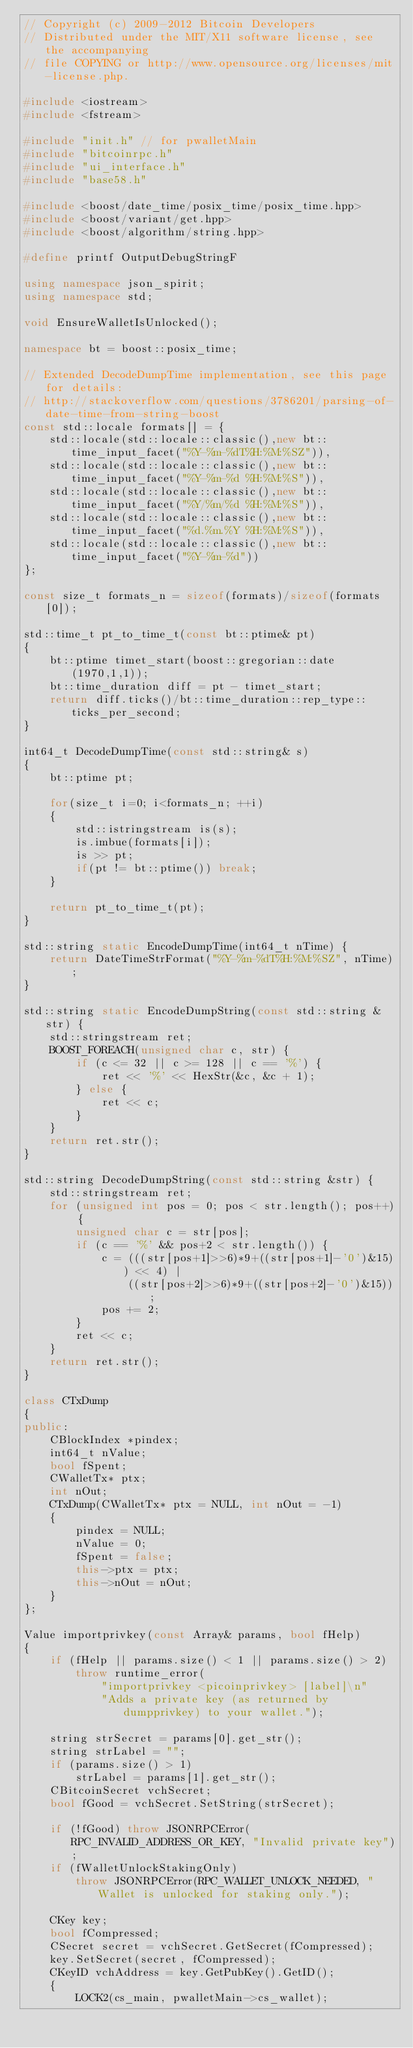<code> <loc_0><loc_0><loc_500><loc_500><_C++_>// Copyright (c) 2009-2012 Bitcoin Developers
// Distributed under the MIT/X11 software license, see the accompanying
// file COPYING or http://www.opensource.org/licenses/mit-license.php.

#include <iostream>
#include <fstream>

#include "init.h" // for pwalletMain
#include "bitcoinrpc.h"
#include "ui_interface.h"
#include "base58.h"

#include <boost/date_time/posix_time/posix_time.hpp>
#include <boost/variant/get.hpp>
#include <boost/algorithm/string.hpp>

#define printf OutputDebugStringF

using namespace json_spirit;
using namespace std;

void EnsureWalletIsUnlocked();

namespace bt = boost::posix_time;

// Extended DecodeDumpTime implementation, see this page for details:
// http://stackoverflow.com/questions/3786201/parsing-of-date-time-from-string-boost
const std::locale formats[] = {
    std::locale(std::locale::classic(),new bt::time_input_facet("%Y-%m-%dT%H:%M:%SZ")),
    std::locale(std::locale::classic(),new bt::time_input_facet("%Y-%m-%d %H:%M:%S")),
    std::locale(std::locale::classic(),new bt::time_input_facet("%Y/%m/%d %H:%M:%S")),
    std::locale(std::locale::classic(),new bt::time_input_facet("%d.%m.%Y %H:%M:%S")),
    std::locale(std::locale::classic(),new bt::time_input_facet("%Y-%m-%d"))
};

const size_t formats_n = sizeof(formats)/sizeof(formats[0]);

std::time_t pt_to_time_t(const bt::ptime& pt)
{
    bt::ptime timet_start(boost::gregorian::date(1970,1,1));
    bt::time_duration diff = pt - timet_start;
    return diff.ticks()/bt::time_duration::rep_type::ticks_per_second;
}

int64_t DecodeDumpTime(const std::string& s)
{
    bt::ptime pt;

    for(size_t i=0; i<formats_n; ++i)
    {
        std::istringstream is(s);
        is.imbue(formats[i]);
        is >> pt;
        if(pt != bt::ptime()) break;
    }

    return pt_to_time_t(pt);
}

std::string static EncodeDumpTime(int64_t nTime) {
    return DateTimeStrFormat("%Y-%m-%dT%H:%M:%SZ", nTime);
}

std::string static EncodeDumpString(const std::string &str) {
    std::stringstream ret;
    BOOST_FOREACH(unsigned char c, str) {
        if (c <= 32 || c >= 128 || c == '%') {
            ret << '%' << HexStr(&c, &c + 1);
        } else {
            ret << c;
        }
    }
    return ret.str();
}

std::string DecodeDumpString(const std::string &str) {
    std::stringstream ret;
    for (unsigned int pos = 0; pos < str.length(); pos++) {
        unsigned char c = str[pos];
        if (c == '%' && pos+2 < str.length()) {
            c = (((str[pos+1]>>6)*9+((str[pos+1]-'0')&15)) << 4) | 
                ((str[pos+2]>>6)*9+((str[pos+2]-'0')&15));
            pos += 2;
        }
        ret << c;
    }
    return ret.str();
}

class CTxDump
{
public:
    CBlockIndex *pindex;
    int64_t nValue;
    bool fSpent;
    CWalletTx* ptx;
    int nOut;
    CTxDump(CWalletTx* ptx = NULL, int nOut = -1)
    {
        pindex = NULL;
        nValue = 0;
        fSpent = false;
        this->ptx = ptx;
        this->nOut = nOut;
    }
};

Value importprivkey(const Array& params, bool fHelp)
{
    if (fHelp || params.size() < 1 || params.size() > 2)
        throw runtime_error(
            "importprivkey <picoinprivkey> [label]\n"
            "Adds a private key (as returned by dumpprivkey) to your wallet.");

    string strSecret = params[0].get_str();
    string strLabel = "";
    if (params.size() > 1)
        strLabel = params[1].get_str();
    CBitcoinSecret vchSecret;
    bool fGood = vchSecret.SetString(strSecret);

    if (!fGood) throw JSONRPCError(RPC_INVALID_ADDRESS_OR_KEY, "Invalid private key");
    if (fWalletUnlockStakingOnly)
        throw JSONRPCError(RPC_WALLET_UNLOCK_NEEDED, "Wallet is unlocked for staking only.");

    CKey key;
    bool fCompressed;
    CSecret secret = vchSecret.GetSecret(fCompressed);
    key.SetSecret(secret, fCompressed);
    CKeyID vchAddress = key.GetPubKey().GetID();
    {
        LOCK2(cs_main, pwalletMain->cs_wallet);
</code> 